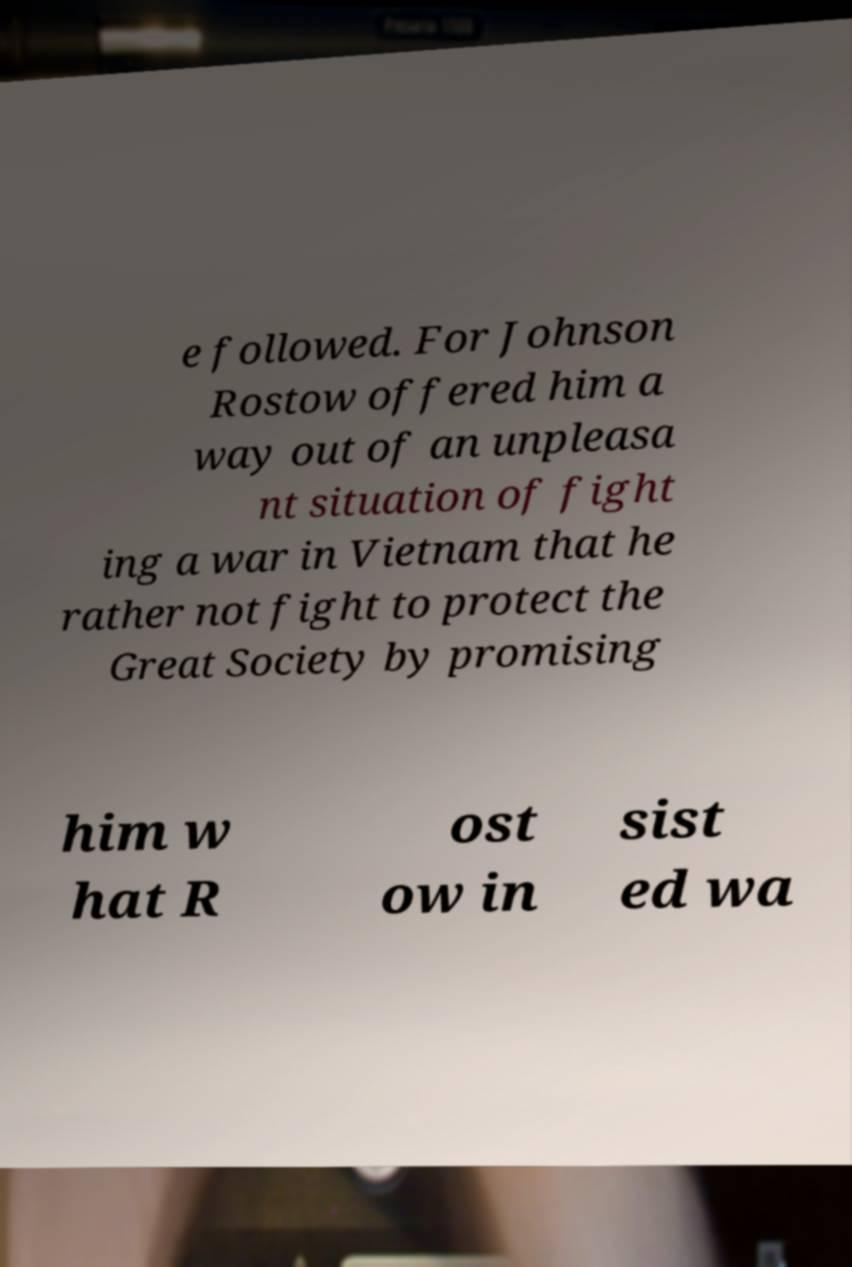Could you extract and type out the text from this image? e followed. For Johnson Rostow offered him a way out of an unpleasa nt situation of fight ing a war in Vietnam that he rather not fight to protect the Great Society by promising him w hat R ost ow in sist ed wa 